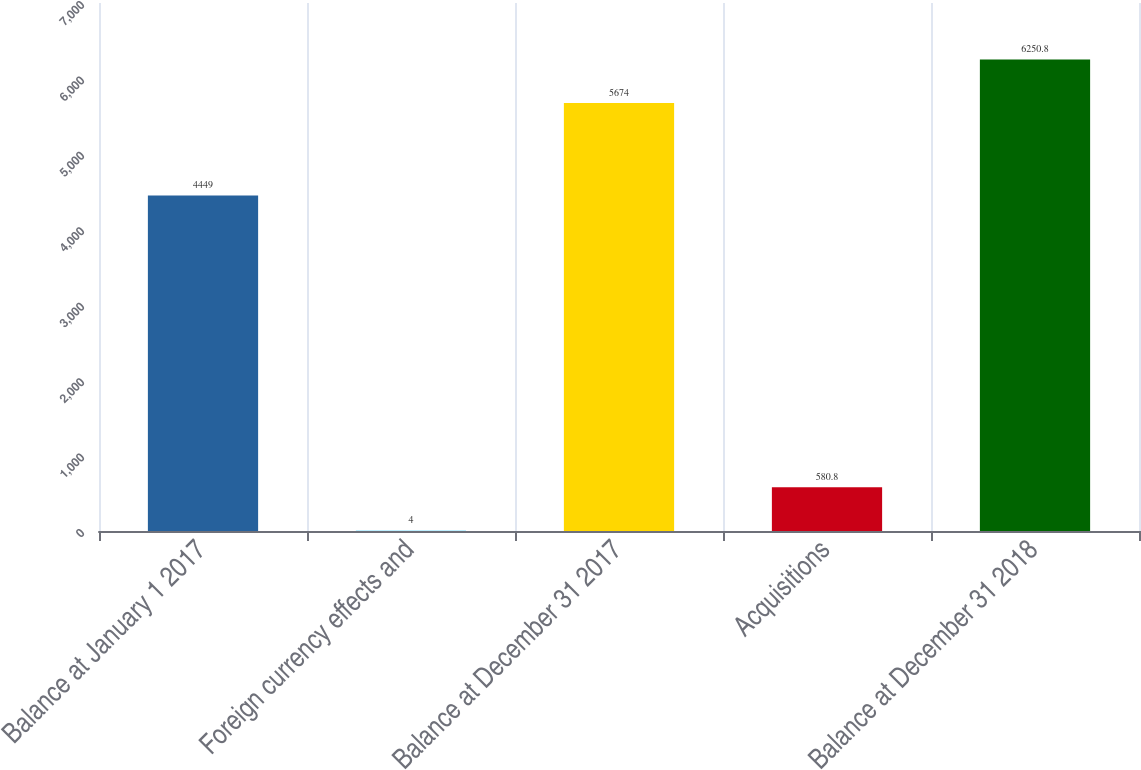<chart> <loc_0><loc_0><loc_500><loc_500><bar_chart><fcel>Balance at January 1 2017<fcel>Foreign currency effects and<fcel>Balance at December 31 2017<fcel>Acquisitions<fcel>Balance at December 31 2018<nl><fcel>4449<fcel>4<fcel>5674<fcel>580.8<fcel>6250.8<nl></chart> 